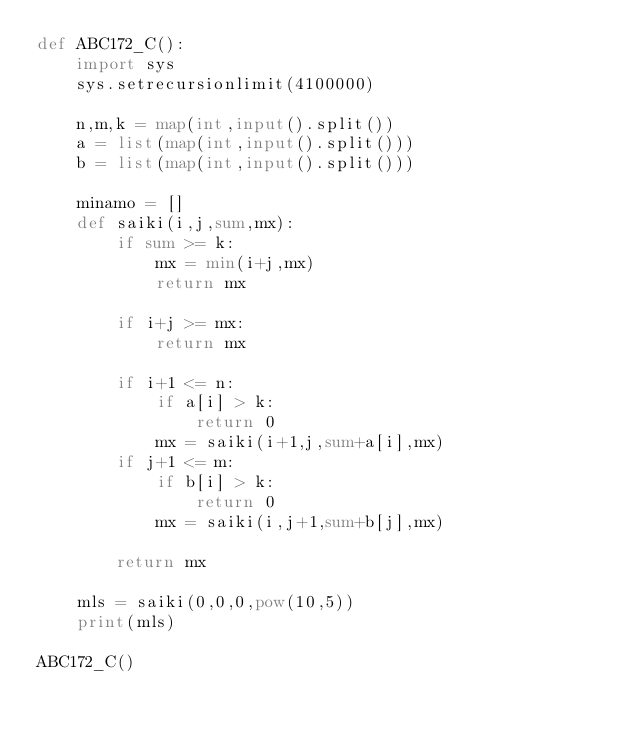<code> <loc_0><loc_0><loc_500><loc_500><_Python_>def ABC172_C():
    import sys
    sys.setrecursionlimit(4100000)

    n,m,k = map(int,input().split())
    a = list(map(int,input().split()))
    b = list(map(int,input().split()))

    minamo = []
    def saiki(i,j,sum,mx):
        if sum >= k:
            mx = min(i+j,mx)
            return mx

        if i+j >= mx:
            return mx

        if i+1 <= n:
            if a[i] > k:
                return 0
            mx = saiki(i+1,j,sum+a[i],mx)
        if j+1 <= m:
            if b[i] > k:
                return 0
            mx = saiki(i,j+1,sum+b[j],mx)

        return mx

    mls = saiki(0,0,0,pow(10,5))
    print(mls)

ABC172_C()</code> 